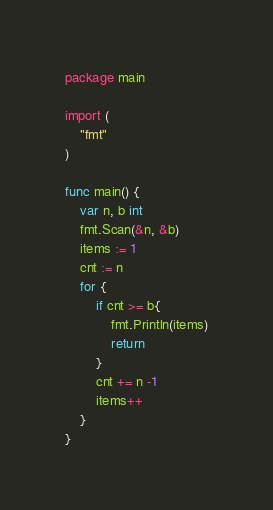Convert code to text. <code><loc_0><loc_0><loc_500><loc_500><_Go_>package main

import (
	"fmt"
)

func main() {
	var n, b int
	fmt.Scan(&n, &b)
	items := 1
	cnt := n
	for {
		if cnt >= b{
			fmt.Println(items)
			return
		}
		cnt += n -1
		items++
	}
}</code> 